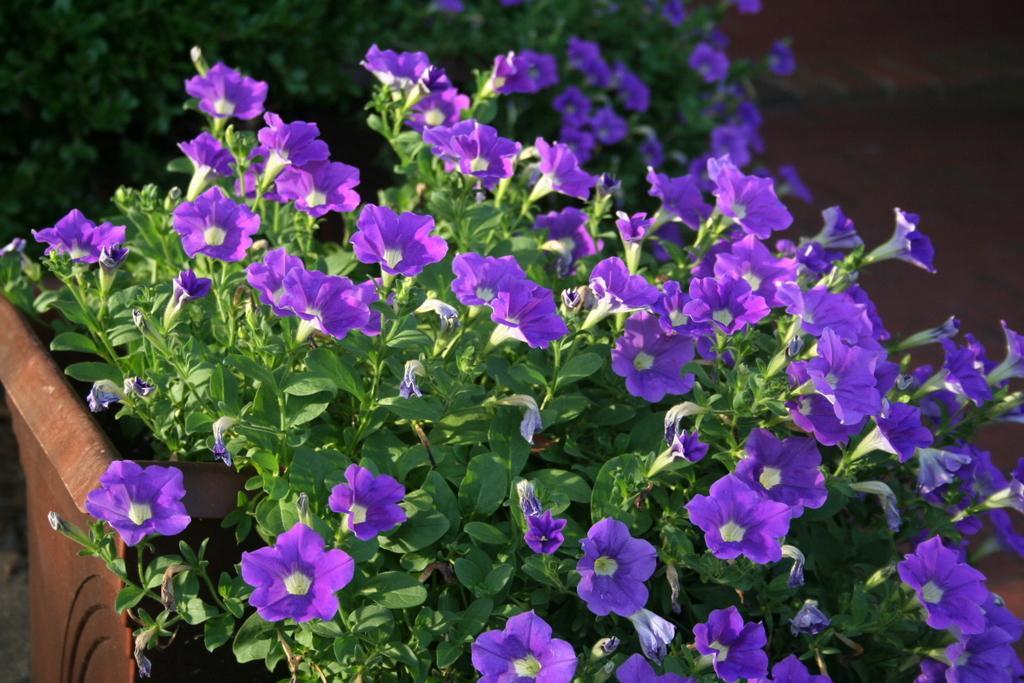How would you summarize this image in a sentence or two? In this image we can see some purple color flowers, flower pots, and some plants. 